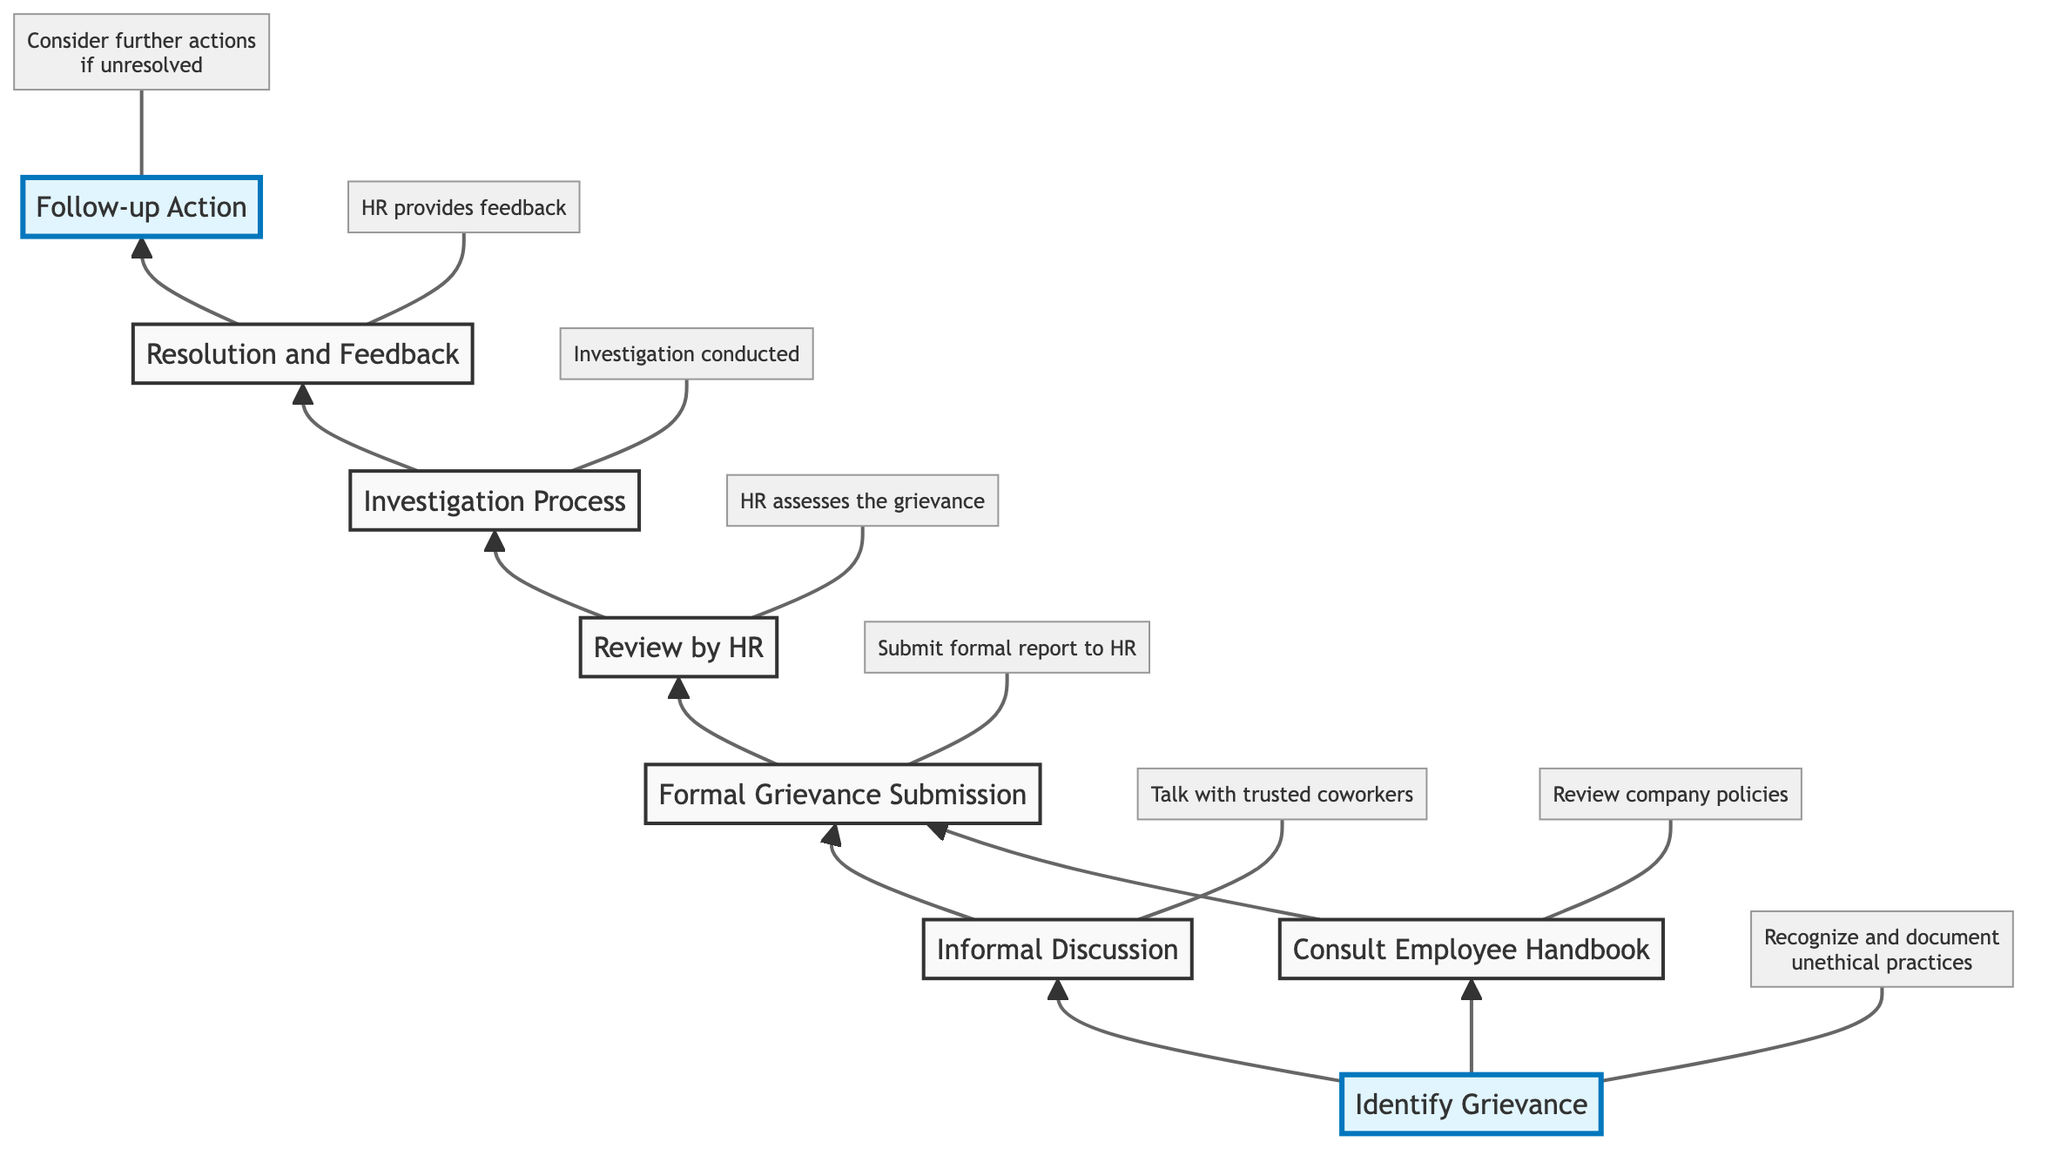What's the first step in the grievance handling process? The first step in the diagram is "Identify Grievance". This is indicated as the starting point of the flow and is labeled clearly at the top.
Answer: Identify Grievance How many total steps are represented in the diagram? The diagram includes a total of eight steps, as it lists each key action in the grievance handling process, from identifying grievances to follow-up actions, clearly marking each.
Answer: Eight What follows the "Formal Grievance Submission"? Following the "Formal Grievance Submission", the next step indicated is "Review by HR". This can be traced directly down the flow from the "Formal Grievance Submission" node.
Answer: Review by HR Which step involves talking with coworkers? The step that involves discussing grievances with coworkers is "Informal Discussion". This is shown as branching directly from "Identify Grievance", emphasizing the importance of initial informal dialogue.
Answer: Informal Discussion What is required after "Investigation Process"? After the "Investigation Process", the next action that follows is "Resolution and Feedback". This movement is clearly indicated in the sequence of actions presented in the flowchart.
Answer: Resolution and Feedback If a grievance is unresolved, what is the last recommended action? The last recommended action if the grievance is unresolved is "Follow-up Action". This step is highlighted in the diagram as an important consideration after the resolution process.
Answer: Follow-up Action What step comes before "Consult Employee Handbook"? The step that comes before "Consult Employee Handbook" is "Identify Grievance". The flowchart shows that both "Informal Discussion" and "Consult Employee Handbook" emerge from this initial identification of the grievance.
Answer: Identify Grievance Which steps are highlighted in the diagram? The highlighted steps in the diagram are "Identify Grievance" and "Follow-up Action". These steps are visually marked to signify their important roles in the grievance handling process.
Answer: Identify Grievance and Follow-up Action 